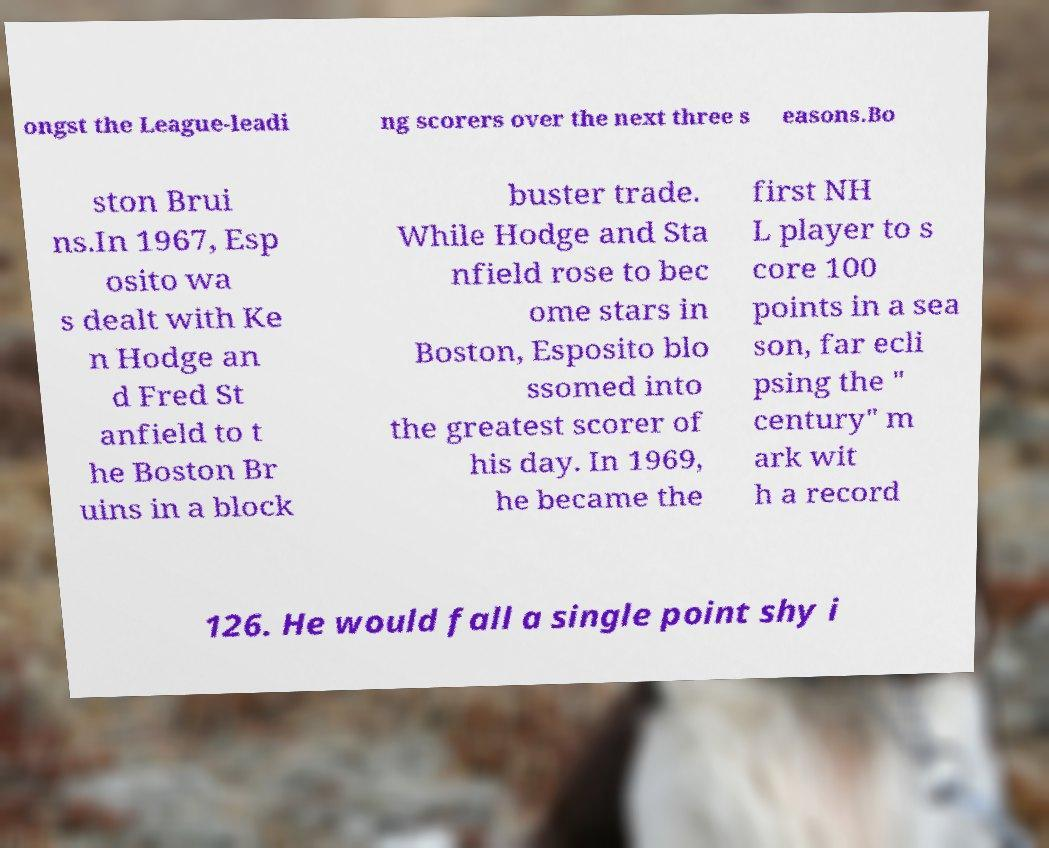What messages or text are displayed in this image? I need them in a readable, typed format. ongst the League-leadi ng scorers over the next three s easons.Bo ston Brui ns.In 1967, Esp osito wa s dealt with Ke n Hodge an d Fred St anfield to t he Boston Br uins in a block buster trade. While Hodge and Sta nfield rose to bec ome stars in Boston, Esposito blo ssomed into the greatest scorer of his day. In 1969, he became the first NH L player to s core 100 points in a sea son, far ecli psing the " century" m ark wit h a record 126. He would fall a single point shy i 